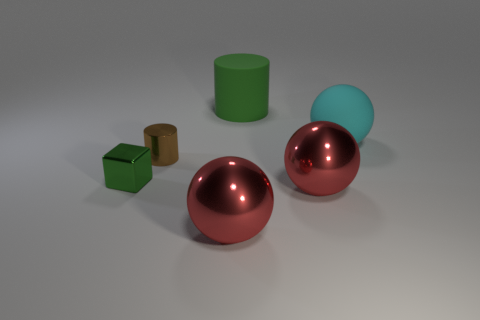Subtract all purple cylinders. How many red balls are left? 2 Subtract all red balls. How many balls are left? 1 Add 1 large red objects. How many objects exist? 7 Subtract all cylinders. How many objects are left? 4 Add 3 large rubber things. How many large rubber things exist? 5 Subtract 0 yellow blocks. How many objects are left? 6 Subtract all small cylinders. Subtract all blocks. How many objects are left? 4 Add 3 tiny green blocks. How many tiny green blocks are left? 4 